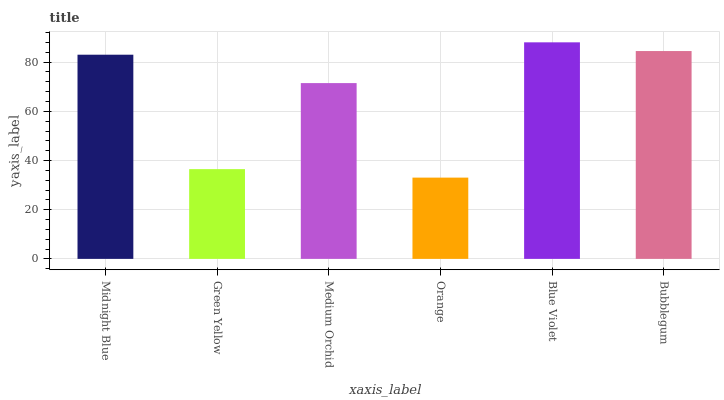Is Orange the minimum?
Answer yes or no. Yes. Is Blue Violet the maximum?
Answer yes or no. Yes. Is Green Yellow the minimum?
Answer yes or no. No. Is Green Yellow the maximum?
Answer yes or no. No. Is Midnight Blue greater than Green Yellow?
Answer yes or no. Yes. Is Green Yellow less than Midnight Blue?
Answer yes or no. Yes. Is Green Yellow greater than Midnight Blue?
Answer yes or no. No. Is Midnight Blue less than Green Yellow?
Answer yes or no. No. Is Midnight Blue the high median?
Answer yes or no. Yes. Is Medium Orchid the low median?
Answer yes or no. Yes. Is Orange the high median?
Answer yes or no. No. Is Bubblegum the low median?
Answer yes or no. No. 